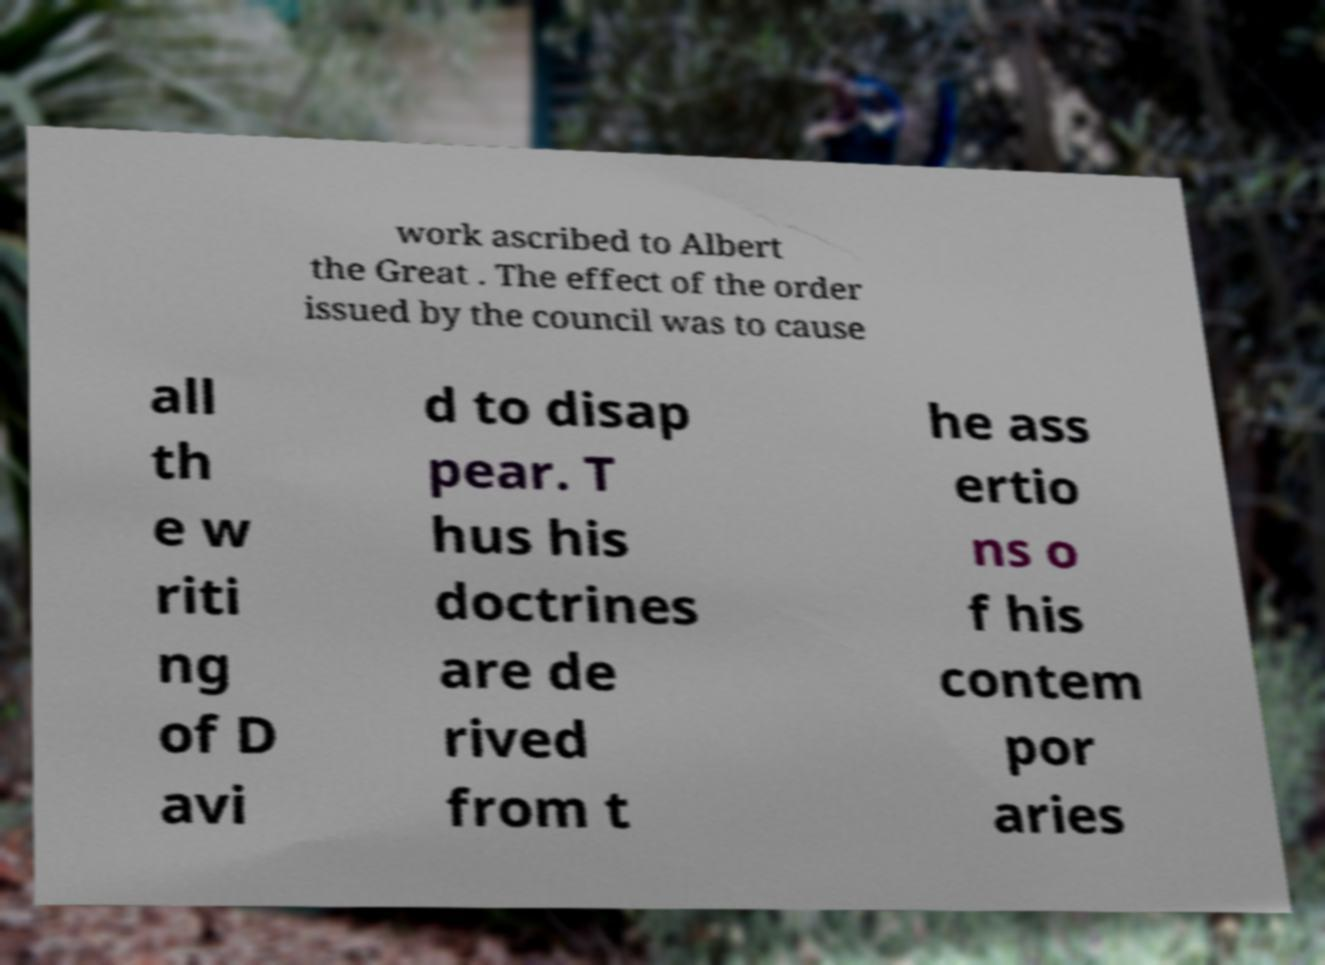Could you extract and type out the text from this image? work ascribed to Albert the Great . The effect of the order issued by the council was to cause all th e w riti ng of D avi d to disap pear. T hus his doctrines are de rived from t he ass ertio ns o f his contem por aries 